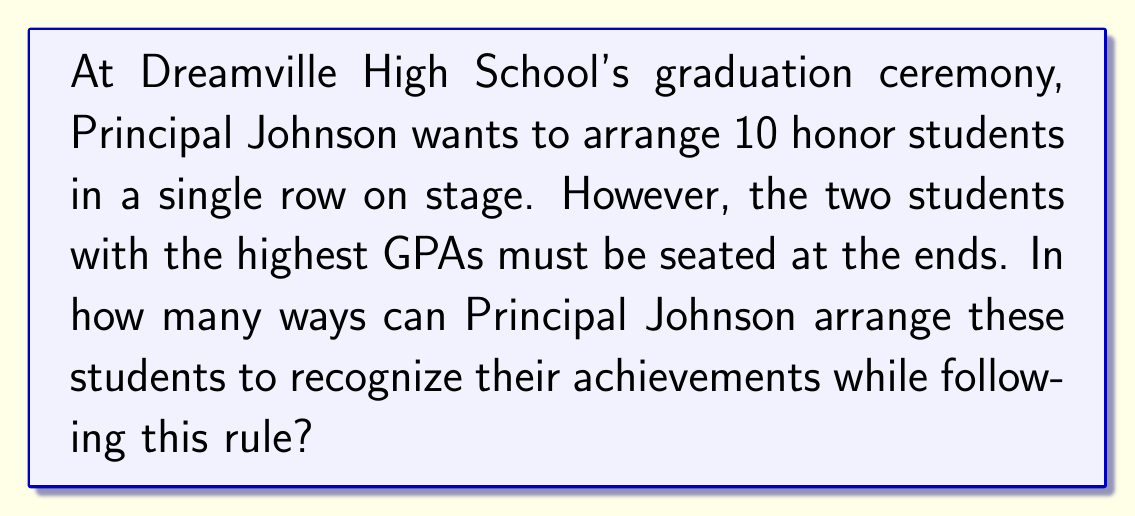Solve this math problem. Let's approach this step-by-step:

1) First, we need to consider the two students with the highest GPAs. They must be seated at the ends, but they can be arranged in 2 ways:
   - Highest GPA on the left, second-highest on the right
   - Second-highest on the left, highest on the right

2) Now, we have 8 remaining students to arrange in the middle 8 positions.

3) This is a straightforward permutation problem. We can arrange 8 students in 8! ways.

4) By the multiplication principle, we multiply the number of ways to arrange the ends (2) by the number of ways to arrange the middle (8!):

   $$ 2 \times 8! $$

5) Let's calculate this:
   $$ 2 \times 8! = 2 \times 40,320 = 80,640 $$

Therefore, Principal Johnson can arrange the 10 honor students in 80,640 different ways.
Answer: 80,640 